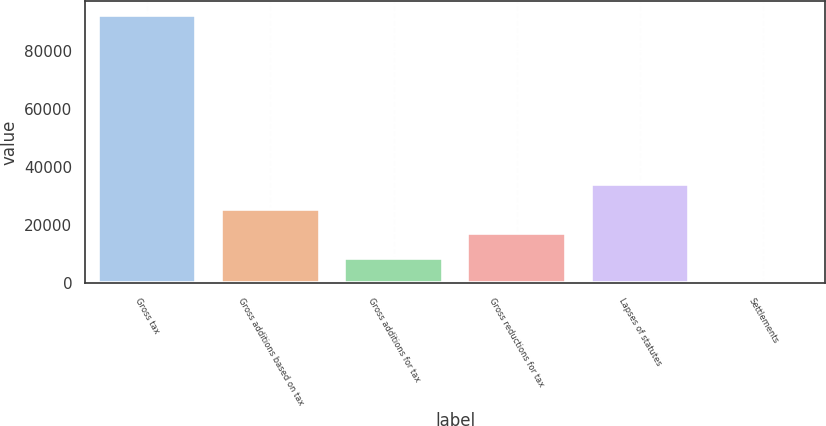<chart> <loc_0><loc_0><loc_500><loc_500><bar_chart><fcel>Gross tax<fcel>Gross additions based on tax<fcel>Gross additions for tax<fcel>Gross reductions for tax<fcel>Lapses of statutes<fcel>Settlements<nl><fcel>92395.4<fcel>25504.2<fcel>8629.4<fcel>17066.8<fcel>33941.6<fcel>192<nl></chart> 